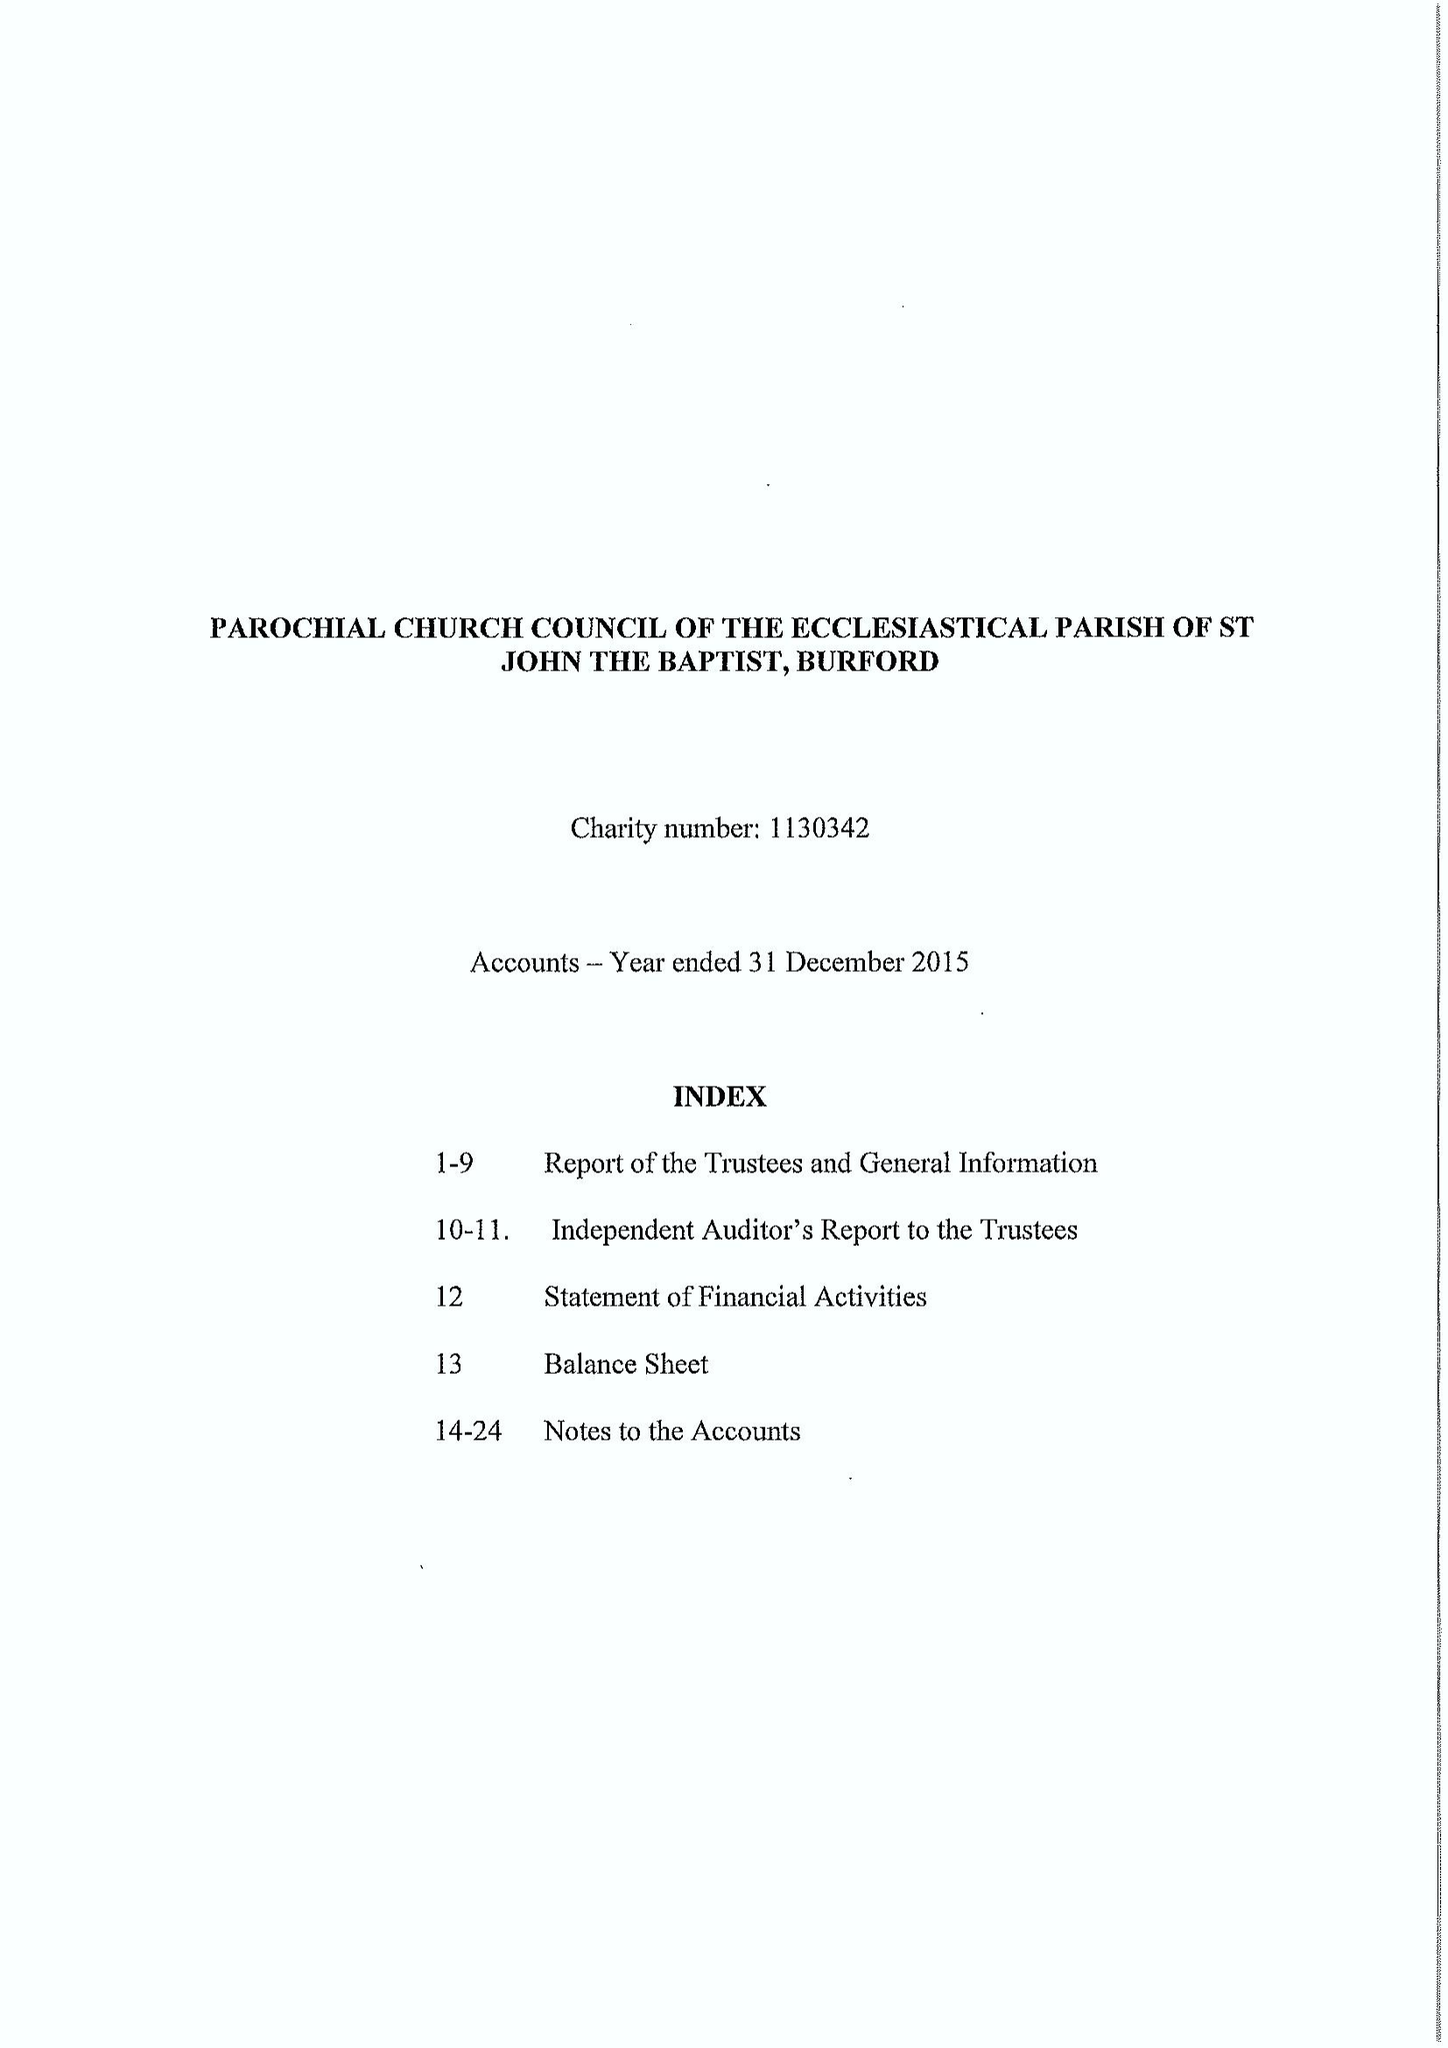What is the value for the address__postcode?
Answer the question using a single word or phrase. OX18 4RZ 